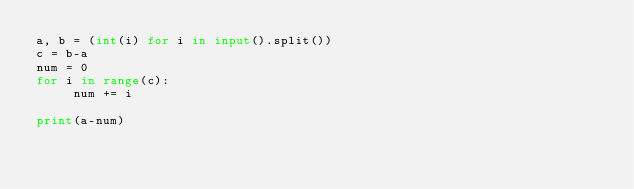Convert code to text. <code><loc_0><loc_0><loc_500><loc_500><_Python_>a, b = (int(i) for i in input().split())  
c = b-a
num = 0
for i in range(c):
     num += i

print(a-num)</code> 